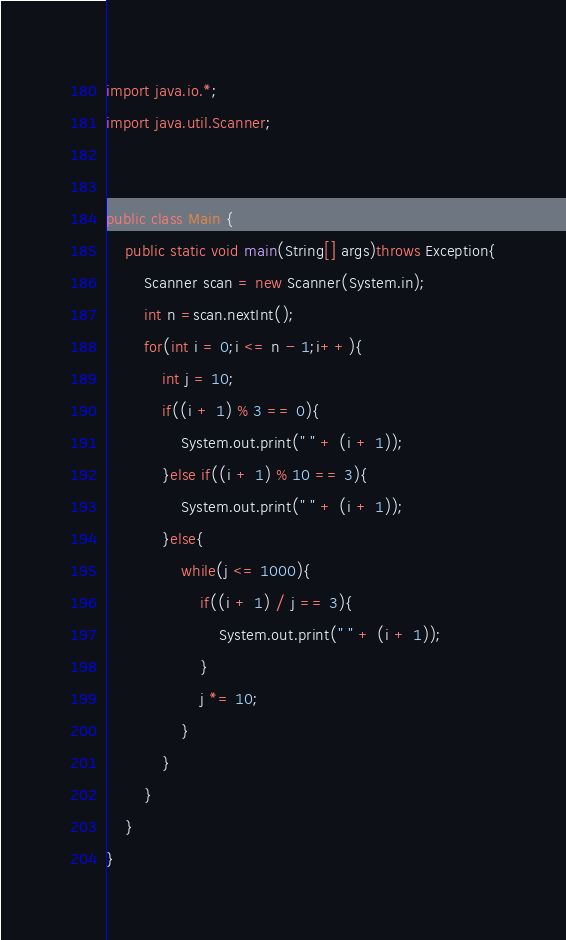<code> <loc_0><loc_0><loc_500><loc_500><_Java_>import java.io.*;
import java.util.Scanner;


public class Main {
    public static void main(String[] args)throws Exception{
        Scanner scan = new Scanner(System.in);
        int n =scan.nextInt();
        for(int i = 0;i <= n - 1;i++){
            int j = 10;
            if((i + 1) % 3 == 0){
                System.out.print(" " + (i + 1));
            }else if((i + 1) % 10 == 3){
                System.out.print(" " + (i + 1));
            }else{
                while(j <= 1000){
                    if((i + 1) / j == 3){
                        System.out.print(" " + (i + 1));
                    }
                    j *= 10;
                }
            }
        }
    }
}
</code> 